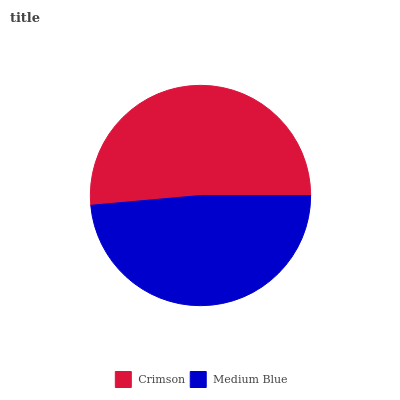Is Medium Blue the minimum?
Answer yes or no. Yes. Is Crimson the maximum?
Answer yes or no. Yes. Is Medium Blue the maximum?
Answer yes or no. No. Is Crimson greater than Medium Blue?
Answer yes or no. Yes. Is Medium Blue less than Crimson?
Answer yes or no. Yes. Is Medium Blue greater than Crimson?
Answer yes or no. No. Is Crimson less than Medium Blue?
Answer yes or no. No. Is Crimson the high median?
Answer yes or no. Yes. Is Medium Blue the low median?
Answer yes or no. Yes. Is Medium Blue the high median?
Answer yes or no. No. Is Crimson the low median?
Answer yes or no. No. 